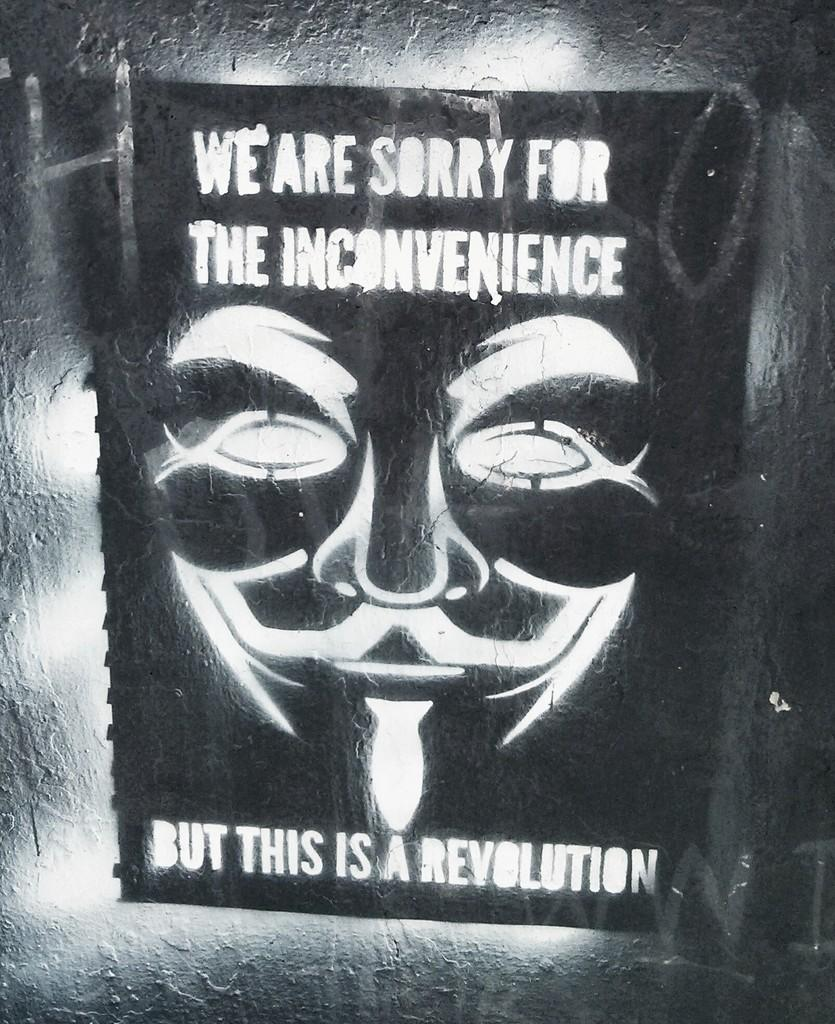What is present on the wall in the image? There is a notice paper attached to the wall. What is depicted on the notice paper? The notice paper contains an image of a person. Is there any text on the notice paper? Yes, the notice paper contains text. Can you see a coach driving through the mountains in the image? No, there is no coach or mountains present in the image. Is there a cake displayed on the notice paper? No, there is no cake depicted on the notice paper; it contains an image of a person and text. 